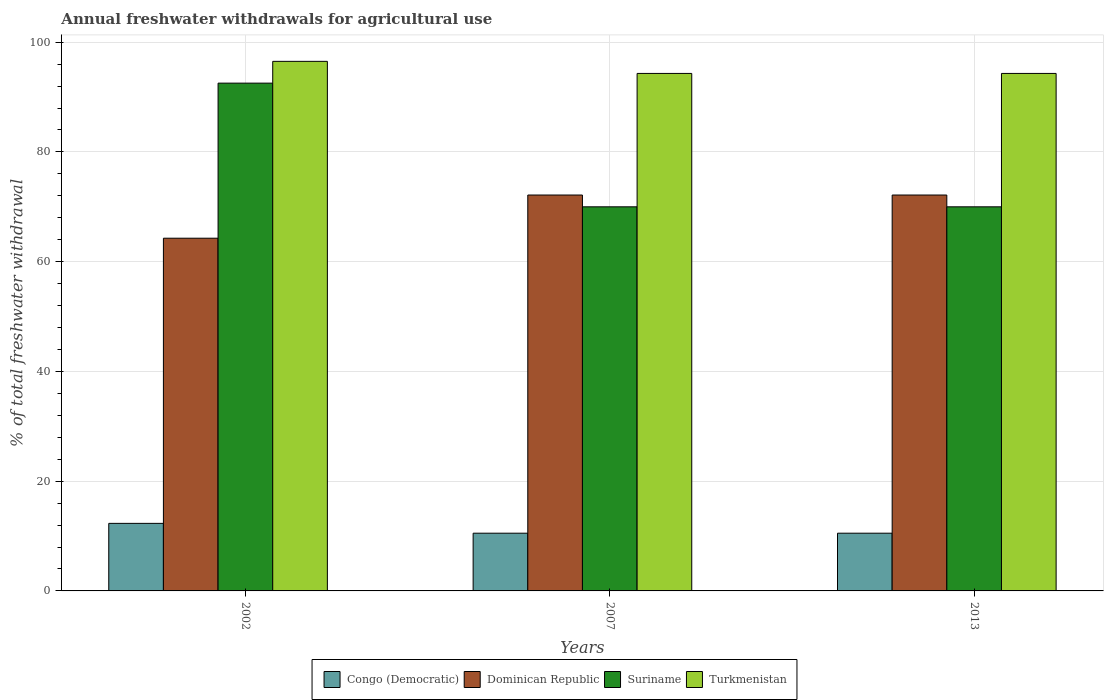How many different coloured bars are there?
Ensure brevity in your answer.  4. How many groups of bars are there?
Keep it short and to the point. 3. How many bars are there on the 3rd tick from the right?
Keep it short and to the point. 4. What is the total annual withdrawals from freshwater in Dominican Republic in 2013?
Offer a terse response. 72.15. Across all years, what is the maximum total annual withdrawals from freshwater in Suriname?
Ensure brevity in your answer.  92.54. Across all years, what is the minimum total annual withdrawals from freshwater in Congo (Democratic)?
Offer a terse response. 10.52. In which year was the total annual withdrawals from freshwater in Congo (Democratic) minimum?
Offer a terse response. 2007. What is the total total annual withdrawals from freshwater in Dominican Republic in the graph?
Keep it short and to the point. 208.58. What is the difference between the total annual withdrawals from freshwater in Dominican Republic in 2007 and that in 2013?
Keep it short and to the point. 0. What is the difference between the total annual withdrawals from freshwater in Congo (Democratic) in 2002 and the total annual withdrawals from freshwater in Turkmenistan in 2013?
Offer a terse response. -82. What is the average total annual withdrawals from freshwater in Dominican Republic per year?
Keep it short and to the point. 69.53. In the year 2002, what is the difference between the total annual withdrawals from freshwater in Congo (Democratic) and total annual withdrawals from freshwater in Suriname?
Make the answer very short. -80.23. In how many years, is the total annual withdrawals from freshwater in Congo (Democratic) greater than 32 %?
Offer a terse response. 0. What is the ratio of the total annual withdrawals from freshwater in Turkmenistan in 2002 to that in 2007?
Offer a very short reply. 1.02. Is the total annual withdrawals from freshwater in Suriname in 2002 less than that in 2007?
Ensure brevity in your answer.  No. Is the difference between the total annual withdrawals from freshwater in Congo (Democratic) in 2002 and 2007 greater than the difference between the total annual withdrawals from freshwater in Suriname in 2002 and 2007?
Give a very brief answer. No. What is the difference between the highest and the second highest total annual withdrawals from freshwater in Suriname?
Ensure brevity in your answer.  22.54. What is the difference between the highest and the lowest total annual withdrawals from freshwater in Suriname?
Make the answer very short. 22.54. Is the sum of the total annual withdrawals from freshwater in Turkmenistan in 2002 and 2007 greater than the maximum total annual withdrawals from freshwater in Suriname across all years?
Offer a terse response. Yes. Is it the case that in every year, the sum of the total annual withdrawals from freshwater in Turkmenistan and total annual withdrawals from freshwater in Congo (Democratic) is greater than the sum of total annual withdrawals from freshwater in Dominican Republic and total annual withdrawals from freshwater in Suriname?
Give a very brief answer. No. What does the 3rd bar from the left in 2007 represents?
Make the answer very short. Suriname. What does the 1st bar from the right in 2007 represents?
Your answer should be very brief. Turkmenistan. Are all the bars in the graph horizontal?
Your response must be concise. No. Are the values on the major ticks of Y-axis written in scientific E-notation?
Your answer should be compact. No. Does the graph contain any zero values?
Give a very brief answer. No. Does the graph contain grids?
Keep it short and to the point. Yes. Where does the legend appear in the graph?
Your answer should be compact. Bottom center. How many legend labels are there?
Make the answer very short. 4. What is the title of the graph?
Provide a succinct answer. Annual freshwater withdrawals for agricultural use. What is the label or title of the Y-axis?
Keep it short and to the point. % of total freshwater withdrawal. What is the % of total freshwater withdrawal in Congo (Democratic) in 2002?
Your response must be concise. 12.31. What is the % of total freshwater withdrawal of Dominican Republic in 2002?
Offer a very short reply. 64.28. What is the % of total freshwater withdrawal in Suriname in 2002?
Your answer should be very brief. 92.54. What is the % of total freshwater withdrawal of Turkmenistan in 2002?
Give a very brief answer. 96.51. What is the % of total freshwater withdrawal in Congo (Democratic) in 2007?
Offer a very short reply. 10.52. What is the % of total freshwater withdrawal of Dominican Republic in 2007?
Your answer should be very brief. 72.15. What is the % of total freshwater withdrawal of Turkmenistan in 2007?
Your answer should be very brief. 94.31. What is the % of total freshwater withdrawal in Congo (Democratic) in 2013?
Give a very brief answer. 10.52. What is the % of total freshwater withdrawal in Dominican Republic in 2013?
Provide a short and direct response. 72.15. What is the % of total freshwater withdrawal in Turkmenistan in 2013?
Provide a short and direct response. 94.31. Across all years, what is the maximum % of total freshwater withdrawal of Congo (Democratic)?
Make the answer very short. 12.31. Across all years, what is the maximum % of total freshwater withdrawal of Dominican Republic?
Provide a succinct answer. 72.15. Across all years, what is the maximum % of total freshwater withdrawal of Suriname?
Give a very brief answer. 92.54. Across all years, what is the maximum % of total freshwater withdrawal in Turkmenistan?
Your answer should be very brief. 96.51. Across all years, what is the minimum % of total freshwater withdrawal of Congo (Democratic)?
Provide a succinct answer. 10.52. Across all years, what is the minimum % of total freshwater withdrawal of Dominican Republic?
Give a very brief answer. 64.28. Across all years, what is the minimum % of total freshwater withdrawal of Turkmenistan?
Your answer should be very brief. 94.31. What is the total % of total freshwater withdrawal of Congo (Democratic) in the graph?
Provide a succinct answer. 33.35. What is the total % of total freshwater withdrawal of Dominican Republic in the graph?
Your answer should be very brief. 208.58. What is the total % of total freshwater withdrawal of Suriname in the graph?
Provide a short and direct response. 232.54. What is the total % of total freshwater withdrawal in Turkmenistan in the graph?
Your answer should be very brief. 285.13. What is the difference between the % of total freshwater withdrawal of Congo (Democratic) in 2002 and that in 2007?
Ensure brevity in your answer.  1.79. What is the difference between the % of total freshwater withdrawal of Dominican Republic in 2002 and that in 2007?
Give a very brief answer. -7.87. What is the difference between the % of total freshwater withdrawal in Suriname in 2002 and that in 2007?
Keep it short and to the point. 22.54. What is the difference between the % of total freshwater withdrawal of Congo (Democratic) in 2002 and that in 2013?
Provide a succinct answer. 1.79. What is the difference between the % of total freshwater withdrawal in Dominican Republic in 2002 and that in 2013?
Offer a very short reply. -7.87. What is the difference between the % of total freshwater withdrawal of Suriname in 2002 and that in 2013?
Provide a succinct answer. 22.54. What is the difference between the % of total freshwater withdrawal of Congo (Democratic) in 2007 and that in 2013?
Provide a short and direct response. 0. What is the difference between the % of total freshwater withdrawal in Suriname in 2007 and that in 2013?
Make the answer very short. 0. What is the difference between the % of total freshwater withdrawal of Congo (Democratic) in 2002 and the % of total freshwater withdrawal of Dominican Republic in 2007?
Give a very brief answer. -59.84. What is the difference between the % of total freshwater withdrawal of Congo (Democratic) in 2002 and the % of total freshwater withdrawal of Suriname in 2007?
Make the answer very short. -57.69. What is the difference between the % of total freshwater withdrawal in Congo (Democratic) in 2002 and the % of total freshwater withdrawal in Turkmenistan in 2007?
Your answer should be very brief. -82. What is the difference between the % of total freshwater withdrawal of Dominican Republic in 2002 and the % of total freshwater withdrawal of Suriname in 2007?
Provide a succinct answer. -5.72. What is the difference between the % of total freshwater withdrawal of Dominican Republic in 2002 and the % of total freshwater withdrawal of Turkmenistan in 2007?
Make the answer very short. -30.03. What is the difference between the % of total freshwater withdrawal of Suriname in 2002 and the % of total freshwater withdrawal of Turkmenistan in 2007?
Your response must be concise. -1.77. What is the difference between the % of total freshwater withdrawal in Congo (Democratic) in 2002 and the % of total freshwater withdrawal in Dominican Republic in 2013?
Give a very brief answer. -59.84. What is the difference between the % of total freshwater withdrawal in Congo (Democratic) in 2002 and the % of total freshwater withdrawal in Suriname in 2013?
Offer a very short reply. -57.69. What is the difference between the % of total freshwater withdrawal in Congo (Democratic) in 2002 and the % of total freshwater withdrawal in Turkmenistan in 2013?
Your response must be concise. -82. What is the difference between the % of total freshwater withdrawal in Dominican Republic in 2002 and the % of total freshwater withdrawal in Suriname in 2013?
Keep it short and to the point. -5.72. What is the difference between the % of total freshwater withdrawal in Dominican Republic in 2002 and the % of total freshwater withdrawal in Turkmenistan in 2013?
Ensure brevity in your answer.  -30.03. What is the difference between the % of total freshwater withdrawal in Suriname in 2002 and the % of total freshwater withdrawal in Turkmenistan in 2013?
Offer a terse response. -1.77. What is the difference between the % of total freshwater withdrawal in Congo (Democratic) in 2007 and the % of total freshwater withdrawal in Dominican Republic in 2013?
Ensure brevity in your answer.  -61.63. What is the difference between the % of total freshwater withdrawal of Congo (Democratic) in 2007 and the % of total freshwater withdrawal of Suriname in 2013?
Provide a succinct answer. -59.48. What is the difference between the % of total freshwater withdrawal in Congo (Democratic) in 2007 and the % of total freshwater withdrawal in Turkmenistan in 2013?
Offer a very short reply. -83.79. What is the difference between the % of total freshwater withdrawal in Dominican Republic in 2007 and the % of total freshwater withdrawal in Suriname in 2013?
Give a very brief answer. 2.15. What is the difference between the % of total freshwater withdrawal of Dominican Republic in 2007 and the % of total freshwater withdrawal of Turkmenistan in 2013?
Provide a short and direct response. -22.16. What is the difference between the % of total freshwater withdrawal of Suriname in 2007 and the % of total freshwater withdrawal of Turkmenistan in 2013?
Your answer should be very brief. -24.31. What is the average % of total freshwater withdrawal of Congo (Democratic) per year?
Offer a terse response. 11.12. What is the average % of total freshwater withdrawal of Dominican Republic per year?
Provide a succinct answer. 69.53. What is the average % of total freshwater withdrawal of Suriname per year?
Offer a terse response. 77.51. What is the average % of total freshwater withdrawal in Turkmenistan per year?
Make the answer very short. 95.04. In the year 2002, what is the difference between the % of total freshwater withdrawal of Congo (Democratic) and % of total freshwater withdrawal of Dominican Republic?
Keep it short and to the point. -51.97. In the year 2002, what is the difference between the % of total freshwater withdrawal of Congo (Democratic) and % of total freshwater withdrawal of Suriname?
Make the answer very short. -80.23. In the year 2002, what is the difference between the % of total freshwater withdrawal in Congo (Democratic) and % of total freshwater withdrawal in Turkmenistan?
Provide a succinct answer. -84.2. In the year 2002, what is the difference between the % of total freshwater withdrawal of Dominican Republic and % of total freshwater withdrawal of Suriname?
Make the answer very short. -28.26. In the year 2002, what is the difference between the % of total freshwater withdrawal in Dominican Republic and % of total freshwater withdrawal in Turkmenistan?
Ensure brevity in your answer.  -32.23. In the year 2002, what is the difference between the % of total freshwater withdrawal in Suriname and % of total freshwater withdrawal in Turkmenistan?
Ensure brevity in your answer.  -3.97. In the year 2007, what is the difference between the % of total freshwater withdrawal in Congo (Democratic) and % of total freshwater withdrawal in Dominican Republic?
Your response must be concise. -61.63. In the year 2007, what is the difference between the % of total freshwater withdrawal of Congo (Democratic) and % of total freshwater withdrawal of Suriname?
Ensure brevity in your answer.  -59.48. In the year 2007, what is the difference between the % of total freshwater withdrawal of Congo (Democratic) and % of total freshwater withdrawal of Turkmenistan?
Offer a very short reply. -83.79. In the year 2007, what is the difference between the % of total freshwater withdrawal of Dominican Republic and % of total freshwater withdrawal of Suriname?
Offer a terse response. 2.15. In the year 2007, what is the difference between the % of total freshwater withdrawal in Dominican Republic and % of total freshwater withdrawal in Turkmenistan?
Provide a succinct answer. -22.16. In the year 2007, what is the difference between the % of total freshwater withdrawal of Suriname and % of total freshwater withdrawal of Turkmenistan?
Provide a succinct answer. -24.31. In the year 2013, what is the difference between the % of total freshwater withdrawal of Congo (Democratic) and % of total freshwater withdrawal of Dominican Republic?
Offer a terse response. -61.63. In the year 2013, what is the difference between the % of total freshwater withdrawal of Congo (Democratic) and % of total freshwater withdrawal of Suriname?
Give a very brief answer. -59.48. In the year 2013, what is the difference between the % of total freshwater withdrawal of Congo (Democratic) and % of total freshwater withdrawal of Turkmenistan?
Keep it short and to the point. -83.79. In the year 2013, what is the difference between the % of total freshwater withdrawal in Dominican Republic and % of total freshwater withdrawal in Suriname?
Your answer should be compact. 2.15. In the year 2013, what is the difference between the % of total freshwater withdrawal of Dominican Republic and % of total freshwater withdrawal of Turkmenistan?
Ensure brevity in your answer.  -22.16. In the year 2013, what is the difference between the % of total freshwater withdrawal in Suriname and % of total freshwater withdrawal in Turkmenistan?
Keep it short and to the point. -24.31. What is the ratio of the % of total freshwater withdrawal in Congo (Democratic) in 2002 to that in 2007?
Ensure brevity in your answer.  1.17. What is the ratio of the % of total freshwater withdrawal in Dominican Republic in 2002 to that in 2007?
Your answer should be very brief. 0.89. What is the ratio of the % of total freshwater withdrawal of Suriname in 2002 to that in 2007?
Your answer should be compact. 1.32. What is the ratio of the % of total freshwater withdrawal of Turkmenistan in 2002 to that in 2007?
Offer a terse response. 1.02. What is the ratio of the % of total freshwater withdrawal of Congo (Democratic) in 2002 to that in 2013?
Keep it short and to the point. 1.17. What is the ratio of the % of total freshwater withdrawal of Dominican Republic in 2002 to that in 2013?
Make the answer very short. 0.89. What is the ratio of the % of total freshwater withdrawal of Suriname in 2002 to that in 2013?
Give a very brief answer. 1.32. What is the ratio of the % of total freshwater withdrawal of Turkmenistan in 2002 to that in 2013?
Provide a succinct answer. 1.02. What is the ratio of the % of total freshwater withdrawal of Dominican Republic in 2007 to that in 2013?
Ensure brevity in your answer.  1. What is the ratio of the % of total freshwater withdrawal of Turkmenistan in 2007 to that in 2013?
Ensure brevity in your answer.  1. What is the difference between the highest and the second highest % of total freshwater withdrawal in Congo (Democratic)?
Provide a succinct answer. 1.79. What is the difference between the highest and the second highest % of total freshwater withdrawal in Dominican Republic?
Your response must be concise. 0. What is the difference between the highest and the second highest % of total freshwater withdrawal in Suriname?
Make the answer very short. 22.54. What is the difference between the highest and the lowest % of total freshwater withdrawal in Congo (Democratic)?
Your answer should be compact. 1.79. What is the difference between the highest and the lowest % of total freshwater withdrawal of Dominican Republic?
Offer a very short reply. 7.87. What is the difference between the highest and the lowest % of total freshwater withdrawal of Suriname?
Keep it short and to the point. 22.54. 